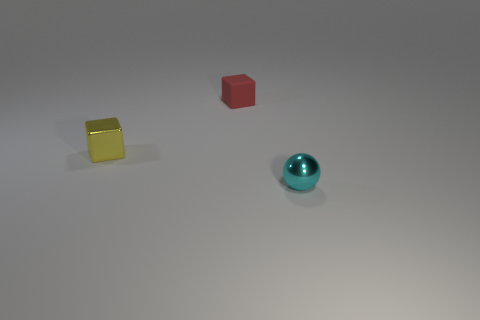Add 1 cyan things. How many objects exist? 4 Subtract all balls. How many objects are left? 2 Subtract all large gray balls. Subtract all red matte blocks. How many objects are left? 2 Add 3 yellow metal blocks. How many yellow metal blocks are left? 4 Add 2 big cyan things. How many big cyan things exist? 2 Subtract 0 brown cylinders. How many objects are left? 3 